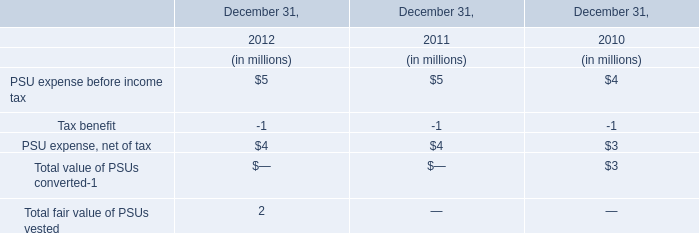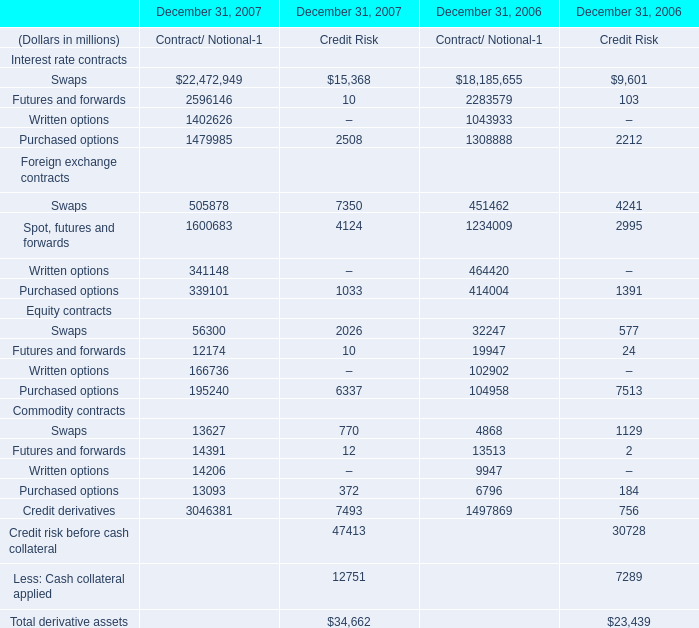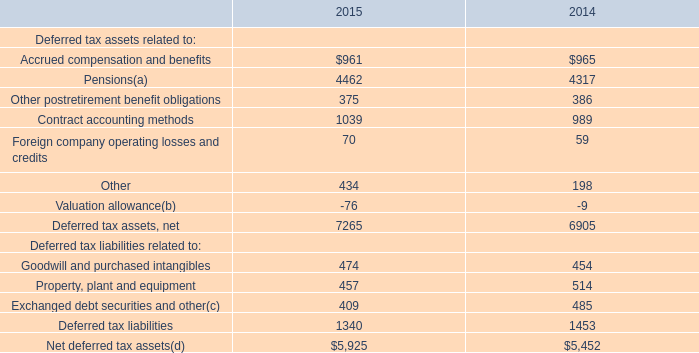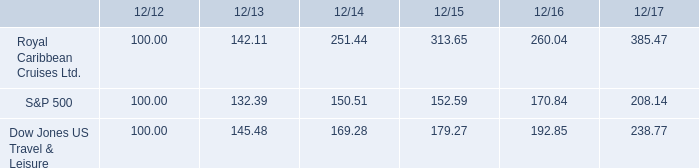what is the mathematical mean for all three investments as of dec 31 , 2017? 
Computations: (((385.47 + 208.14) + 238.77) / 3)
Answer: 277.46. 